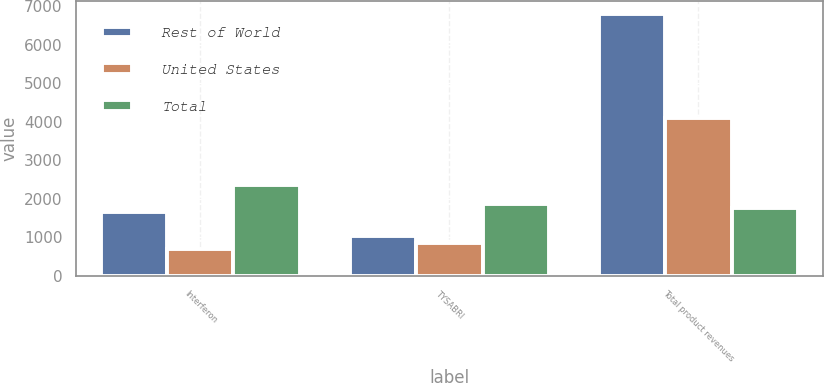Convert chart. <chart><loc_0><loc_0><loc_500><loc_500><stacked_bar_chart><ecel><fcel>Interferon<fcel>TYSABRI<fcel>Total product revenues<nl><fcel>Rest of World<fcel>1668.3<fcel>1025<fcel>6800.5<nl><fcel>United States<fcel>694.7<fcel>839<fcel>4086.3<nl><fcel>Total<fcel>2363<fcel>1864<fcel>1766.15<nl></chart> 